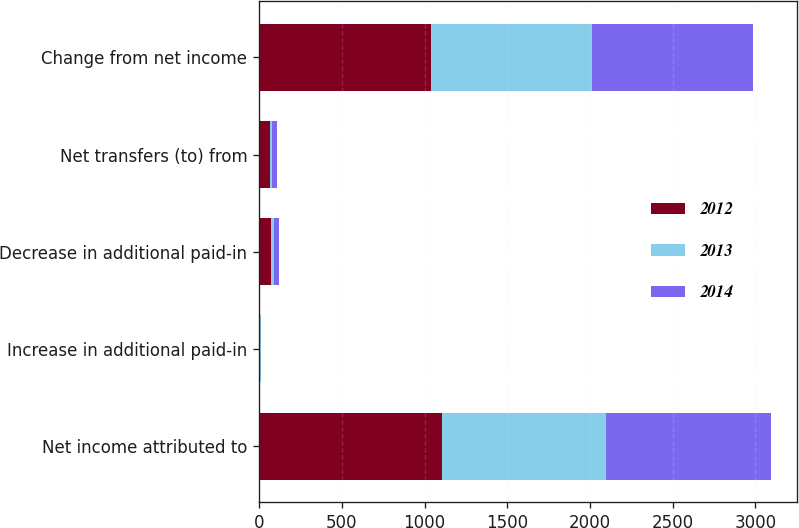<chart> <loc_0><loc_0><loc_500><loc_500><stacked_bar_chart><ecel><fcel>Net income attributed to<fcel>Increase in additional paid-in<fcel>Decrease in additional paid-in<fcel>Net transfers (to) from<fcel>Change from net income<nl><fcel>2012<fcel>1104<fcel>6.3<fcel>70.8<fcel>64.5<fcel>1039.5<nl><fcel>2013<fcel>991.1<fcel>5.2<fcel>22<fcel>16.8<fcel>974.3<nl><fcel>2014<fcel>998.3<fcel>2.6<fcel>30.7<fcel>28.1<fcel>970.2<nl></chart> 